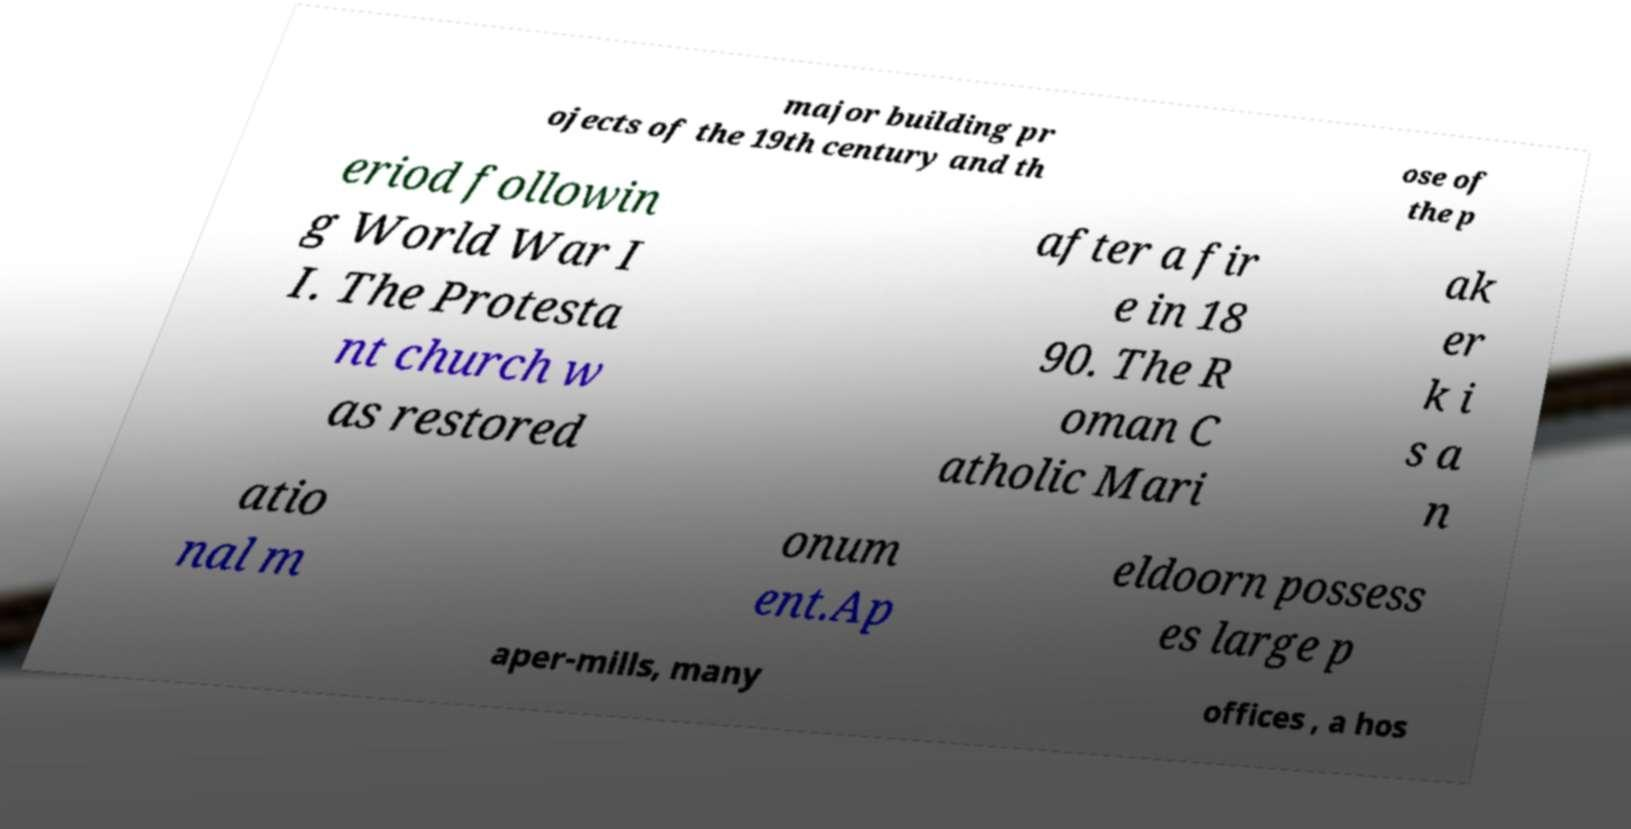There's text embedded in this image that I need extracted. Can you transcribe it verbatim? major building pr ojects of the 19th century and th ose of the p eriod followin g World War I I. The Protesta nt church w as restored after a fir e in 18 90. The R oman C atholic Mari ak er k i s a n atio nal m onum ent.Ap eldoorn possess es large p aper-mills, many offices , a hos 